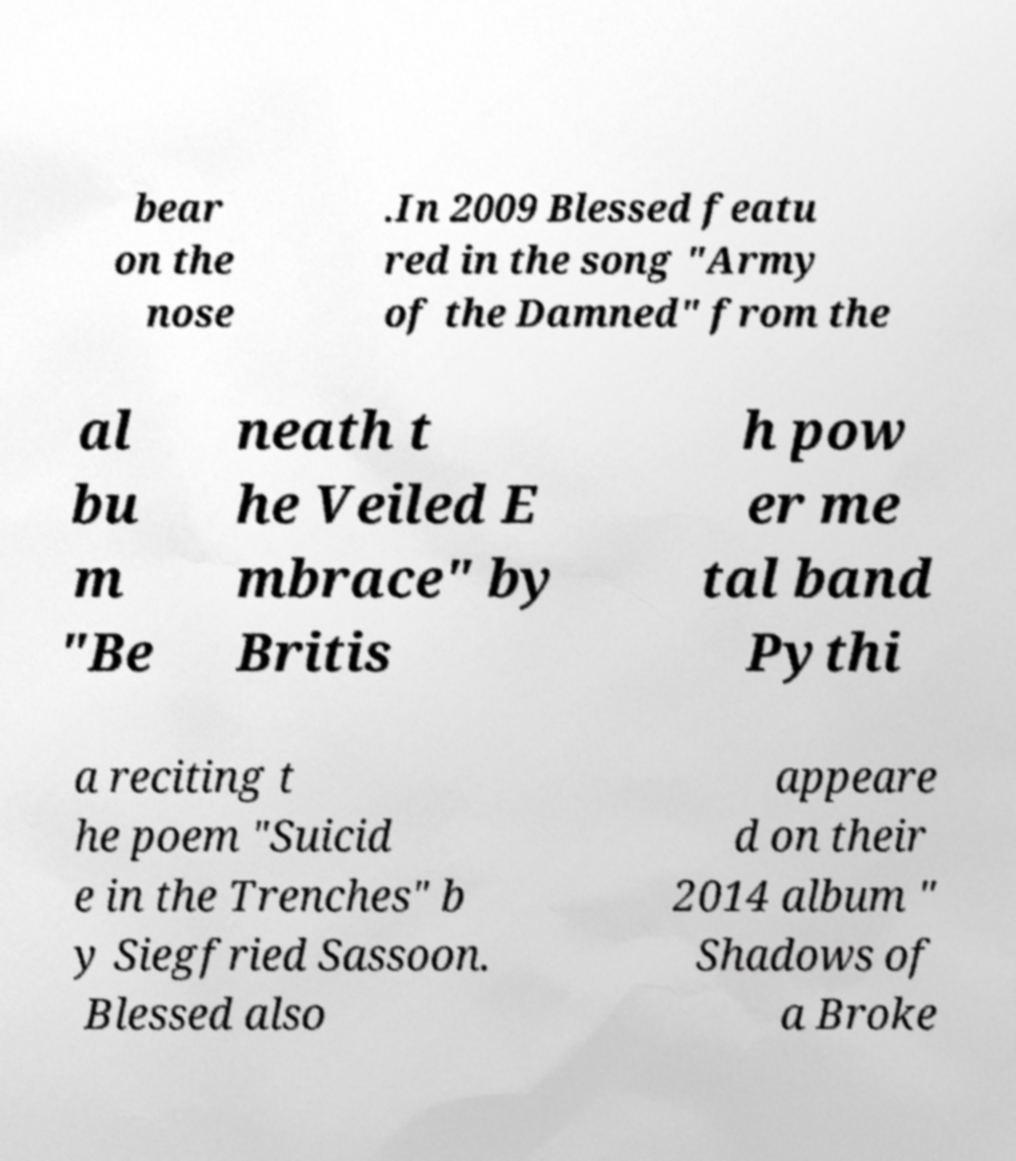Could you extract and type out the text from this image? bear on the nose .In 2009 Blessed featu red in the song "Army of the Damned" from the al bu m "Be neath t he Veiled E mbrace" by Britis h pow er me tal band Pythi a reciting t he poem "Suicid e in the Trenches" b y Siegfried Sassoon. Blessed also appeare d on their 2014 album " Shadows of a Broke 